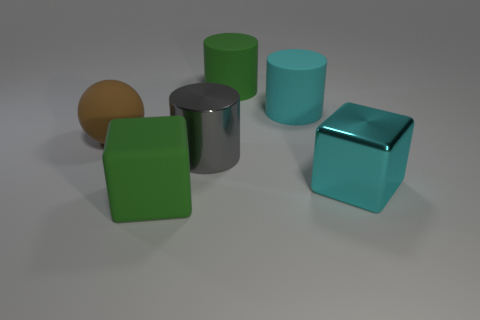What number of other things are there of the same color as the big shiny cube?
Make the answer very short. 1. Is the number of green rubber things greater than the number of tiny yellow rubber objects?
Offer a very short reply. Yes. Do the metallic block and the green rubber thing that is behind the brown matte ball have the same size?
Make the answer very short. Yes. There is a matte object that is left of the green rubber block; what color is it?
Provide a succinct answer. Brown. What number of red things are big objects or large rubber cubes?
Offer a very short reply. 0. The large matte cube has what color?
Your answer should be very brief. Green. Is the number of cylinders in front of the big green block less than the number of balls that are left of the brown object?
Make the answer very short. No. There is a big object that is both in front of the cyan cylinder and on the right side of the big green rubber cylinder; what is its shape?
Ensure brevity in your answer.  Cube. What number of large green matte objects have the same shape as the big gray thing?
Provide a short and direct response. 1. There is a brown ball that is the same material as the big green cylinder; what is its size?
Give a very brief answer. Large. 